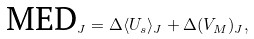<formula> <loc_0><loc_0><loc_500><loc_500>\text {MED} _ { J } = \Delta \langle U _ { s } \rangle _ { J } + \Delta ( V _ { M } ) _ { J } ,</formula> 